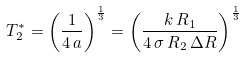Convert formula to latex. <formula><loc_0><loc_0><loc_500><loc_500>T _ { 2 } ^ { * } = \left ( \frac { 1 } { 4 \, a } \right ) ^ { \frac { 1 } { 3 } } = \left ( \frac { k \, R _ { 1 } } { 4 \, \sigma \, R _ { 2 } \, \Delta R } \right ) ^ { \frac { 1 } { 3 } }</formula> 